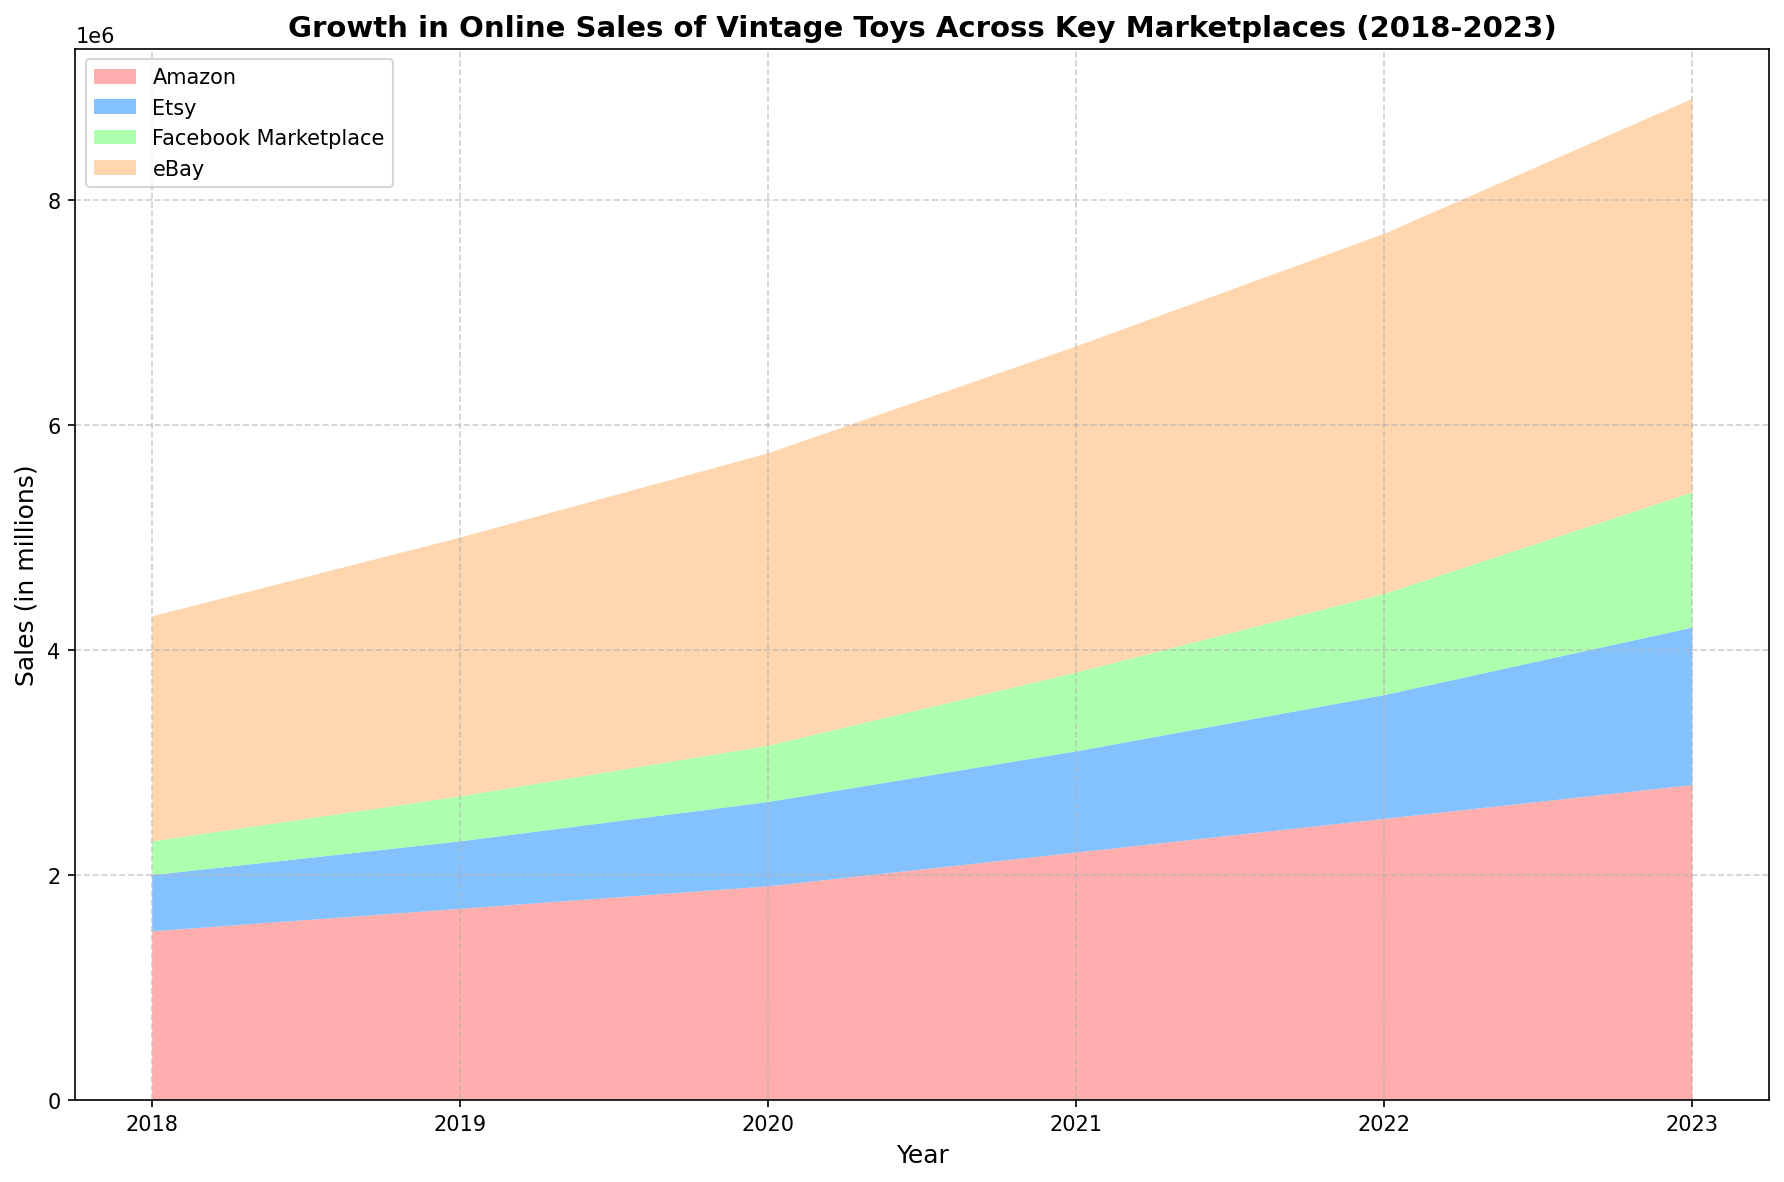What year had the highest total sales across all marketplaces? To find the highest total sales year, sum the sales of all marketplaces for each year and compare. 2023 has the highest with eBay (3500000) + Amazon (2800000) + Etsy (1400000) + Facebook Marketplace (1200000) = 8900000
Answer: 2023 Which marketplace saw the fastest growth in sales between 2018 and 2023? Calculate the difference in sales from 2018 to 2023 for each marketplace. eBay: 3500000 - 2000000 = 1500000, Amazon: 2800000 - 1500000 = 1300000, Etsy: 1400000 - 500000 = 900000, Facebook Marketplace: 1200000 - 300000 = 900000. eBay saw the fastest growth with 1500000
Answer: eBay What is the average annual sales growth for Etsy between 2018 and 2023? Calculate the yearly growth, then average it. Growths are: (600000-500000), (750000-600000), (900000-750000), (1100000-900000), (1400000-1100000), which results in [100000, 150000, 150000, 200000, 300000]. Average growth = (100000 + 150000 + 150000 + 200000 + 300000) / 5 = 180000
Answer: 180000 In which year did Facebook Marketplace experience the highest spike in sales? Look at year-over-year increases for Facebook Marketplace. From 2018 to 2019: 100000, 2019 to 2020: 100000, 2020 to 2021: 200000, 2021 to 2022: 200000, 2022 to 2023: 300000. The highest spike was in 2023.
Answer: 2023 Which two years have the closest total sales for Amazon? Compare the total sales of Amazon across different years and find the smallest difference. The closest are 2022 and 2023 with a difference of 2800000 - 2500000 = 300000
Answer: 2022 and 2023 Which marketplace consistently ranked last in sales throughout the years 2018 to 2023? By examining the lowest sales value each year, Facebook Marketplace consistently ranks last with lower sales compared to eBay, Amazon, and Etsy.
Answer: Facebook Marketplace How did the sales trend for Amazon change from 2020 to 2023? Observing yearly increases: From 2020 (1900000) to 2021 (2200000) increase by 300000, from 2021 (2200000) to 2022 (2500000) increase by 300000, from 2022 (2500000) to 2023 (2800000) increase by 300000. The trend is consistently increasing by 300000 per year.
Answer: Consistent increase Which year experienced the biggest total increase in sales across all marketplaces compared to the previous year? Calculate the total increase year by year. The greatest increase is from 2022 to 2023: (3500000 + 2800000 + 1400000 + 1200000) - (3200000 + 2500000 + 1100000 + 900000) = 8900000 - 7700000 = 1200000
Answer: 2023 